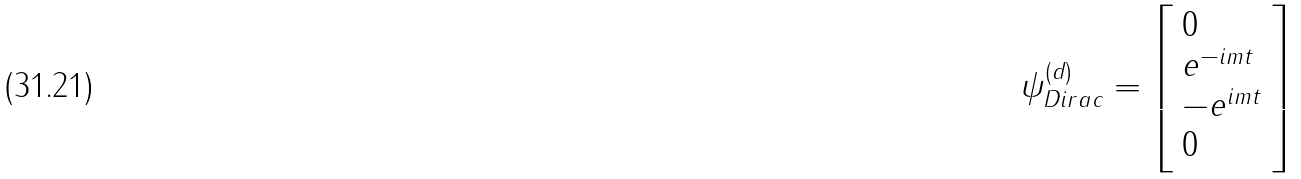Convert formula to latex. <formula><loc_0><loc_0><loc_500><loc_500>\psi _ { D i r a c } ^ { ( d ) } = { \left [ \begin{array} { l } { 0 } \\ { e ^ { - i m t } } \\ { - e ^ { i m t } } \\ { 0 } \end{array} \right ] }</formula> 